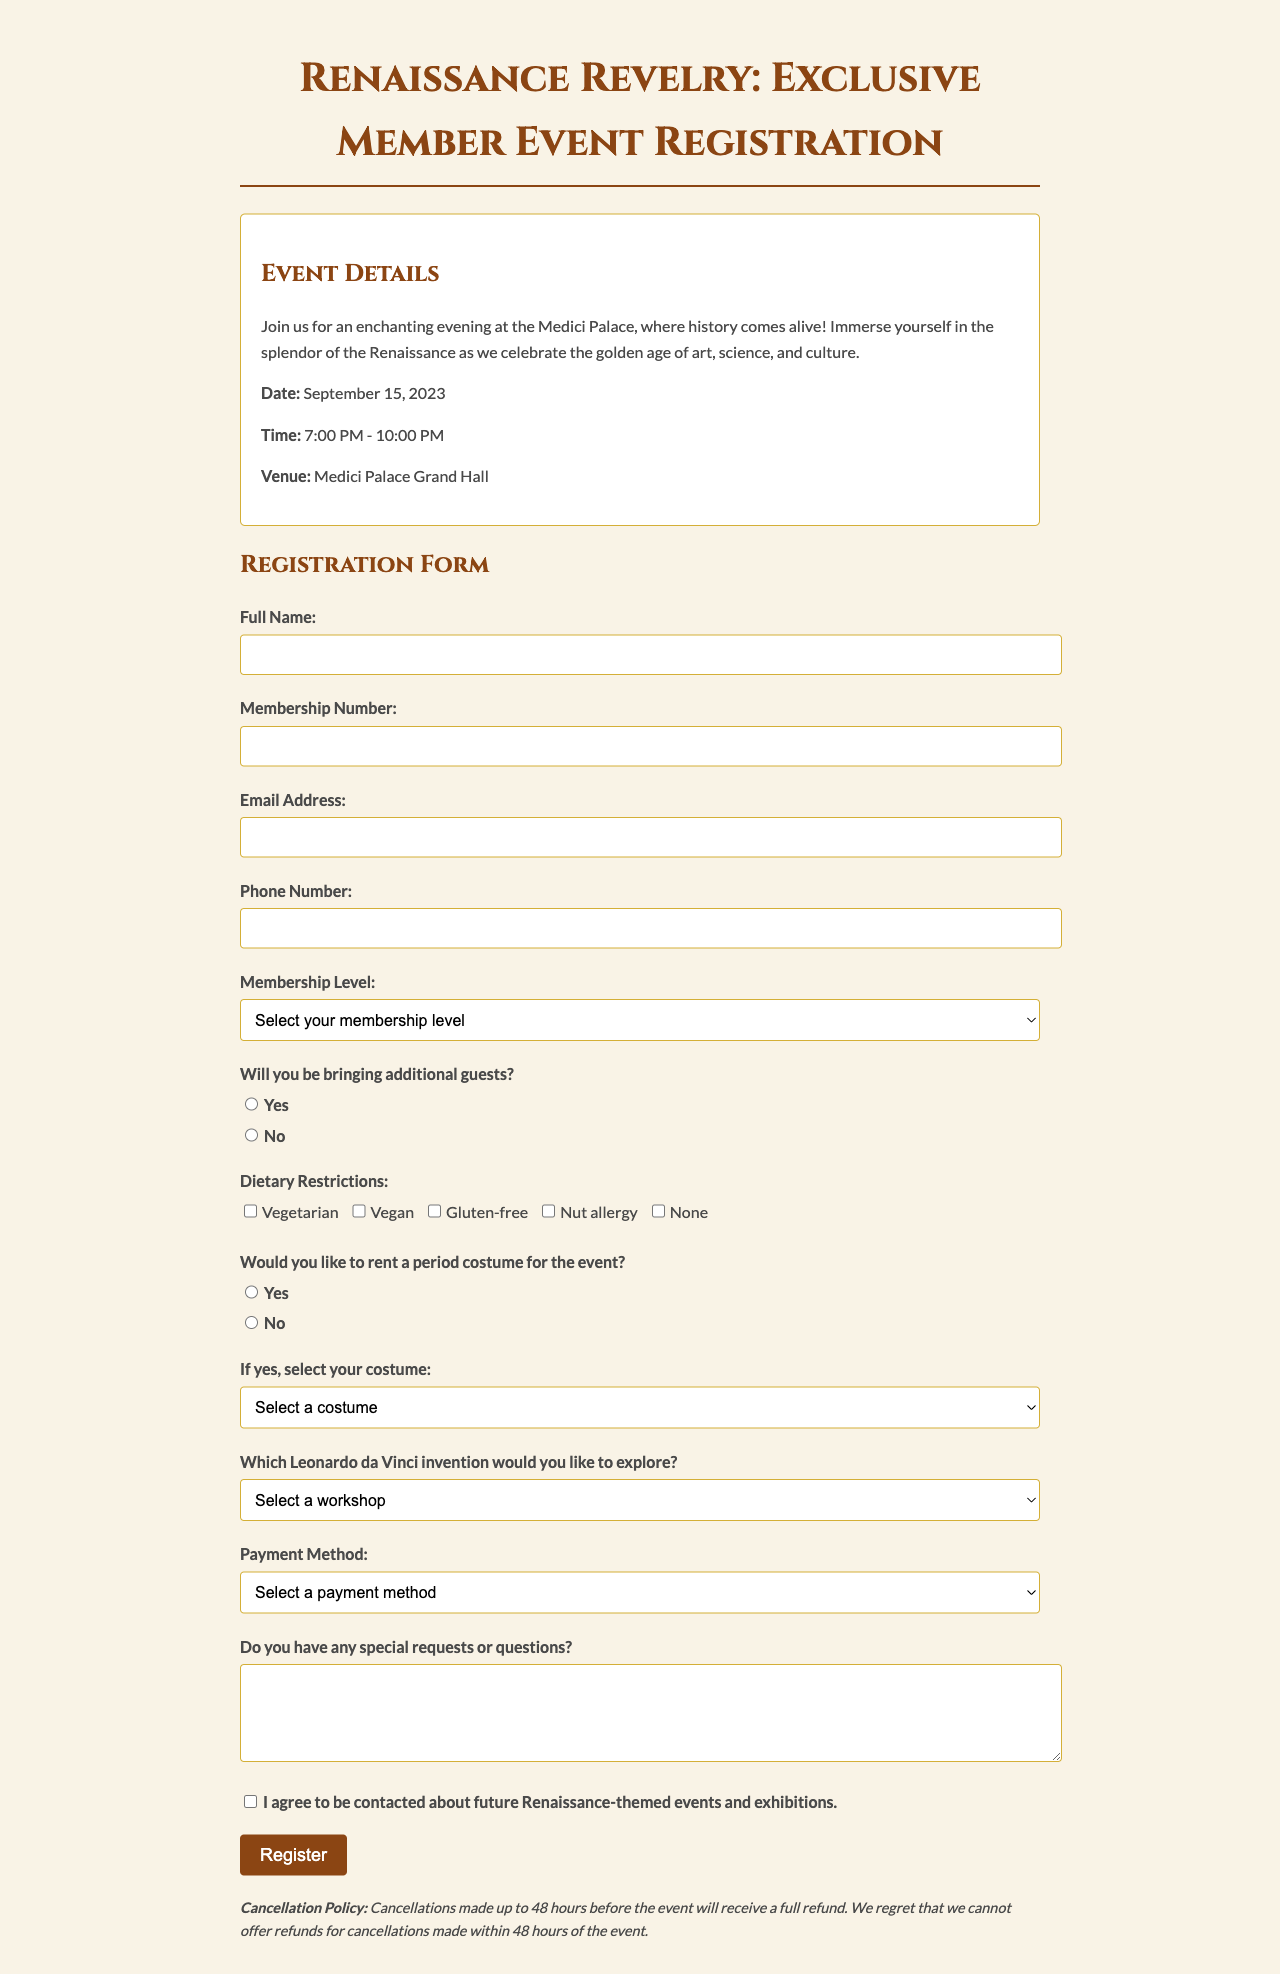What is the event date? The event date is mentioned under Event Details in the document.
Answer: September 15, 2023 Where is the event being held? The venue of the event is specified in the Event Details section.
Answer: Medici Palace Grand Hall What time does the event start? The event time is provided in the Event Details section of the document.
Answer: 7:00 PM How many activities are listed for the event? The document lists the activities under the event, counting them provides the answer.
Answer: 4 What is the maximum number of additional guests one can bring? The document specifies the maximum number of additional guests in the Additional Guests section.
Answer: 2 Which membership level is listed last? The membership levels are listed sequentially, and the last one provides the answer.
Answer: Patron of the Arts Is there a workshop preference question in the form? The document includes a section for workshop preferences, indicating it is present.
Answer: Yes What is the cancellation policy regarding refunds? The cancellation policy details are specified in the document.
Answer: Full refund if canceled 48 hours in advance 